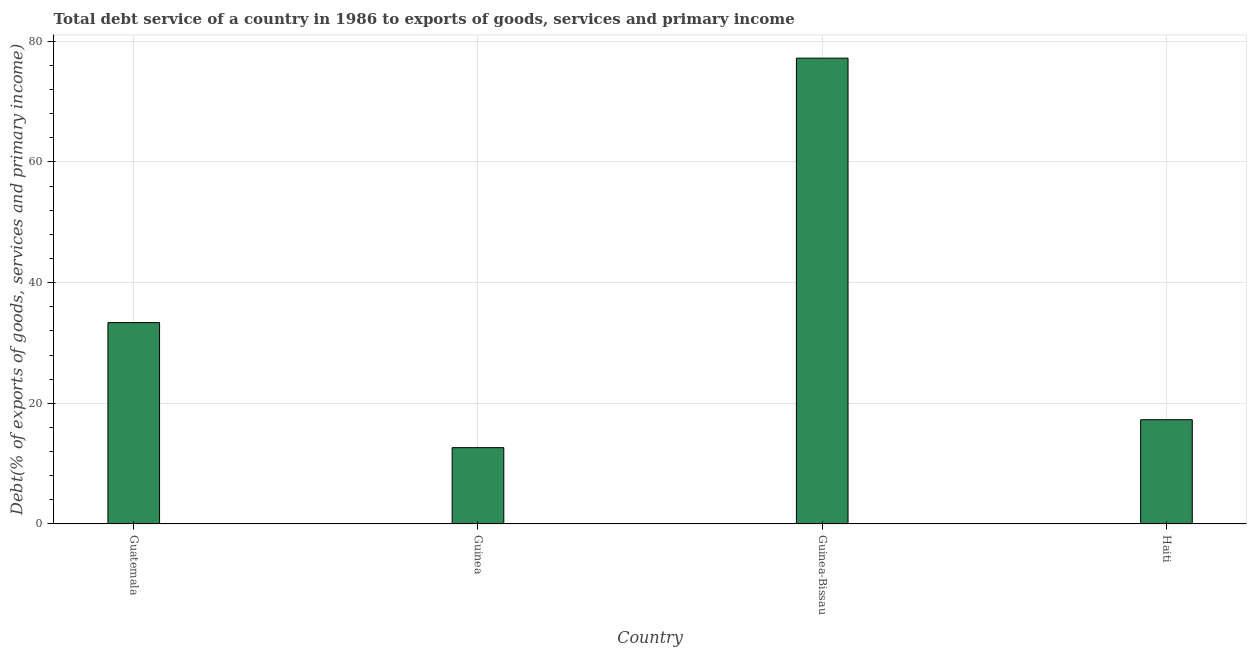Does the graph contain any zero values?
Provide a short and direct response. No. What is the title of the graph?
Ensure brevity in your answer.  Total debt service of a country in 1986 to exports of goods, services and primary income. What is the label or title of the Y-axis?
Offer a terse response. Debt(% of exports of goods, services and primary income). What is the total debt service in Guinea?
Your answer should be very brief. 12.65. Across all countries, what is the maximum total debt service?
Keep it short and to the point. 77.2. Across all countries, what is the minimum total debt service?
Your answer should be compact. 12.65. In which country was the total debt service maximum?
Offer a terse response. Guinea-Bissau. In which country was the total debt service minimum?
Your answer should be compact. Guinea. What is the sum of the total debt service?
Make the answer very short. 140.49. What is the difference between the total debt service in Guinea-Bissau and Haiti?
Keep it short and to the point. 59.92. What is the average total debt service per country?
Offer a terse response. 35.12. What is the median total debt service?
Provide a succinct answer. 25.32. In how many countries, is the total debt service greater than 12 %?
Your answer should be very brief. 4. What is the ratio of the total debt service in Guatemala to that in Haiti?
Give a very brief answer. 1.93. Is the difference between the total debt service in Guatemala and Guinea-Bissau greater than the difference between any two countries?
Your answer should be very brief. No. What is the difference between the highest and the second highest total debt service?
Provide a succinct answer. 43.83. Is the sum of the total debt service in Guatemala and Guinea greater than the maximum total debt service across all countries?
Your answer should be very brief. No. What is the difference between the highest and the lowest total debt service?
Offer a very short reply. 64.55. How many bars are there?
Make the answer very short. 4. Are all the bars in the graph horizontal?
Offer a very short reply. No. How many countries are there in the graph?
Provide a succinct answer. 4. Are the values on the major ticks of Y-axis written in scientific E-notation?
Ensure brevity in your answer.  No. What is the Debt(% of exports of goods, services and primary income) of Guatemala?
Your answer should be compact. 33.37. What is the Debt(% of exports of goods, services and primary income) in Guinea?
Make the answer very short. 12.65. What is the Debt(% of exports of goods, services and primary income) in Guinea-Bissau?
Offer a terse response. 77.2. What is the Debt(% of exports of goods, services and primary income) of Haiti?
Give a very brief answer. 17.28. What is the difference between the Debt(% of exports of goods, services and primary income) in Guatemala and Guinea?
Your answer should be compact. 20.72. What is the difference between the Debt(% of exports of goods, services and primary income) in Guatemala and Guinea-Bissau?
Offer a very short reply. -43.83. What is the difference between the Debt(% of exports of goods, services and primary income) in Guatemala and Haiti?
Your answer should be compact. 16.09. What is the difference between the Debt(% of exports of goods, services and primary income) in Guinea and Guinea-Bissau?
Ensure brevity in your answer.  -64.55. What is the difference between the Debt(% of exports of goods, services and primary income) in Guinea and Haiti?
Keep it short and to the point. -4.63. What is the difference between the Debt(% of exports of goods, services and primary income) in Guinea-Bissau and Haiti?
Your answer should be compact. 59.92. What is the ratio of the Debt(% of exports of goods, services and primary income) in Guatemala to that in Guinea?
Provide a short and direct response. 2.64. What is the ratio of the Debt(% of exports of goods, services and primary income) in Guatemala to that in Guinea-Bissau?
Keep it short and to the point. 0.43. What is the ratio of the Debt(% of exports of goods, services and primary income) in Guatemala to that in Haiti?
Your answer should be compact. 1.93. What is the ratio of the Debt(% of exports of goods, services and primary income) in Guinea to that in Guinea-Bissau?
Ensure brevity in your answer.  0.16. What is the ratio of the Debt(% of exports of goods, services and primary income) in Guinea to that in Haiti?
Your answer should be compact. 0.73. What is the ratio of the Debt(% of exports of goods, services and primary income) in Guinea-Bissau to that in Haiti?
Your response must be concise. 4.47. 